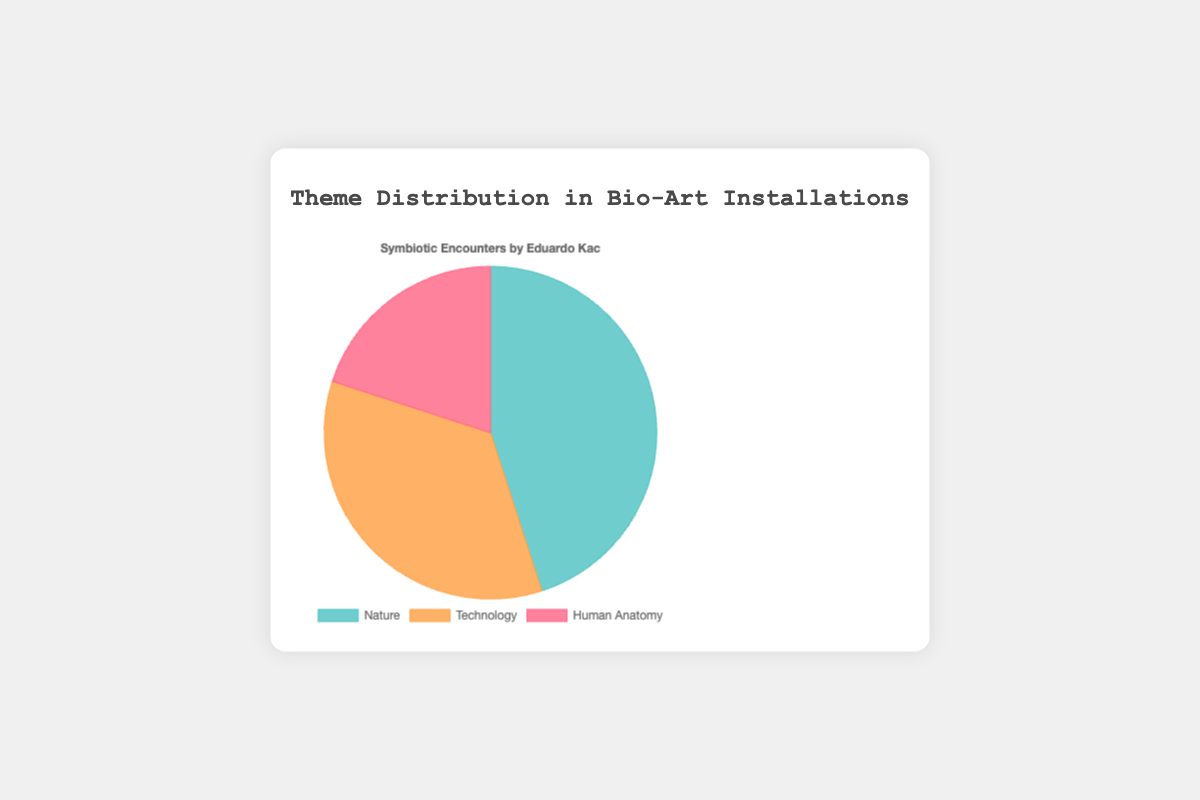What is the percentage distribution of the themes "Nature", "Technology", and "Human Anatomy"? From the pie chart, "Nature" has 45%, "Technology" has 35%, and "Human Anatomy" has 20%.
Answer: Nature 45%, Technology 35%, Human Anatomy 20% Which theme has the largest visual segment in the pie chart? The largest segment in the pie chart corresponds to the theme that takes up 45% of the distribution. This is "Nature".
Answer: Nature What is the combined percentage of "Technology" and "Human Anatomy"? To find the combined percentage, sum the percentages for "Technology" and "Human Anatomy": 35% + 20% = 55%.
Answer: 55% How much larger is the "Nature" theme compared to the "Human Anatomy" theme in percentage points? Subtract the percentage of "Human Anatomy" from the percentage of "Nature": 45% - 20% = 25%.
Answer: 25% Which two themes together make up more than half of the distribution? Adding the percentages for both "Nature" and "Technology" gives 45% + 35% = 80%, which is greater than 50%. Therefore, "Nature" and "Technology" together make up more than half of the distribution.
Answer: Nature and Technology What are the colors representing the themes in the pie chart? The themes are represented by the following colors: "Nature" is a shade of green, "Technology" is a shade of orange, and "Human Anatomy" is a shade of red.
Answer: Green (Nature), Orange (Technology), Red (Human Anatomy) If you combine "Nature" and "Human Anatomy", what is the total percentage, and how does it compare to "Technology"? The combined percentage of "Nature" and "Human Anatomy" is 45% + 20% = 65%. This is greater than "Technology"'s 35% by 30 percentage points.
Answer: 65%, 30 percentage points Between "Technology" and "Human Anatomy", which theme has a larger visual representation, and by how much? "Technology" has a larger representation at 35% compared to "Human Anatomy" at 20%. The difference is 35% - 20% = 15 percentage points.
Answer: Technology, 15 percentage points 